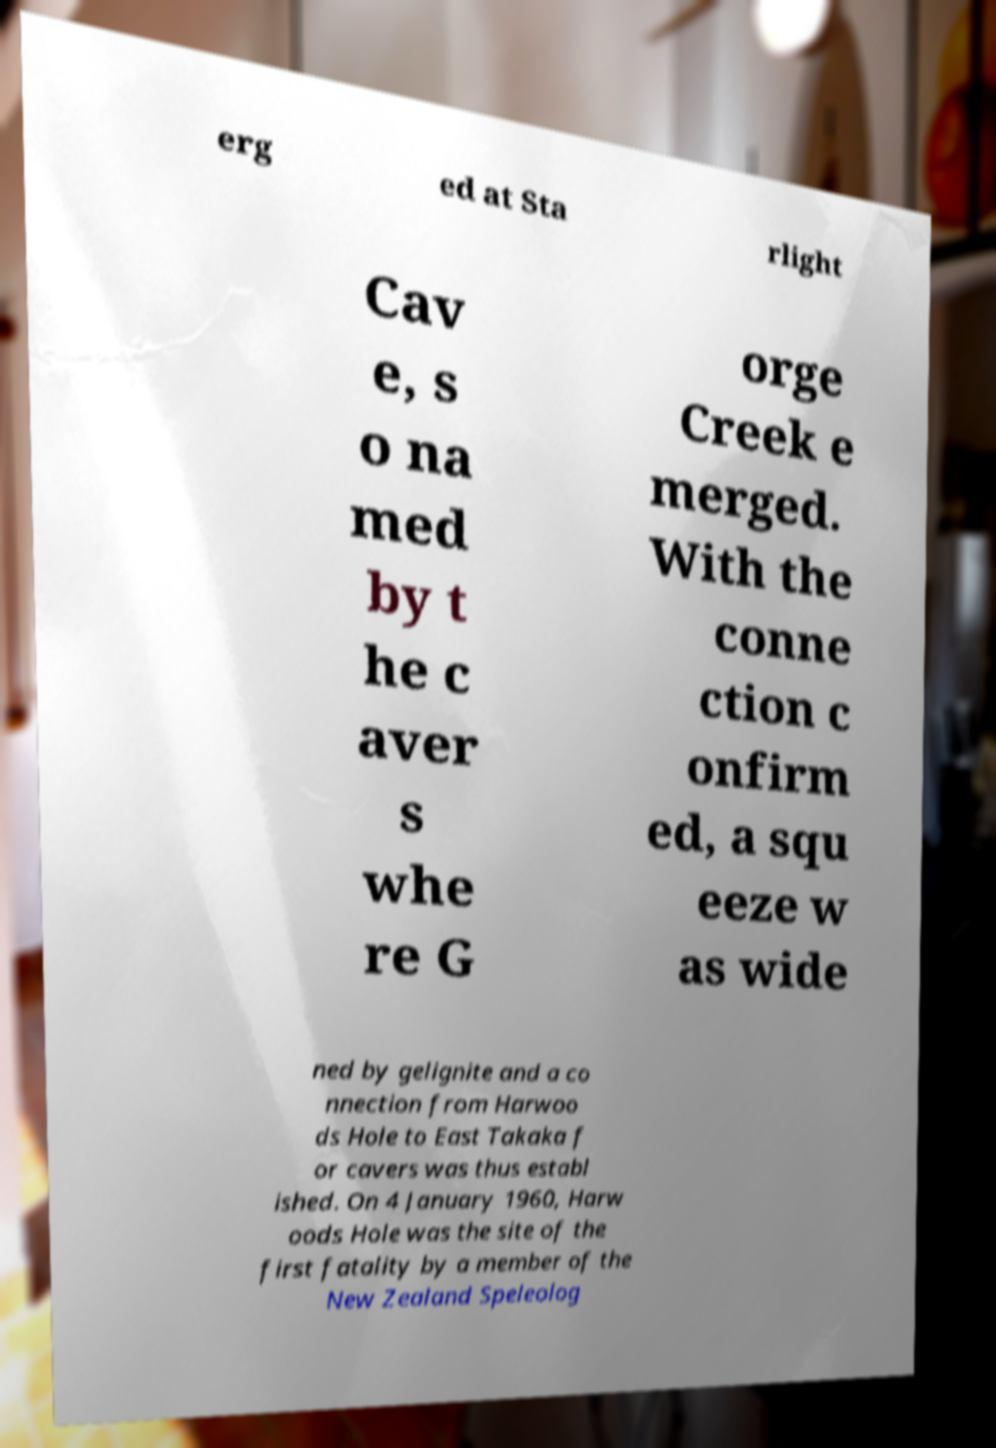What messages or text are displayed in this image? I need them in a readable, typed format. erg ed at Sta rlight Cav e, s o na med by t he c aver s whe re G orge Creek e merged. With the conne ction c onfirm ed, a squ eeze w as wide ned by gelignite and a co nnection from Harwoo ds Hole to East Takaka f or cavers was thus establ ished. On 4 January 1960, Harw oods Hole was the site of the first fatality by a member of the New Zealand Speleolog 